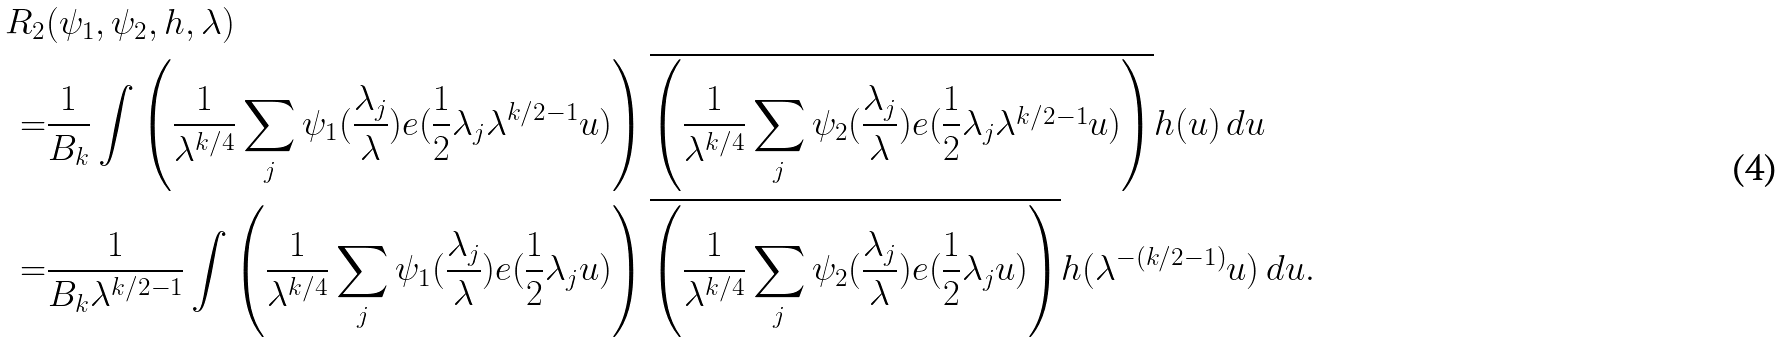Convert formula to latex. <formula><loc_0><loc_0><loc_500><loc_500>R _ { 2 } & ( \psi _ { 1 } , \psi _ { 2 } , h , \lambda ) \\ = & \frac { 1 } { B _ { k } } \int \left ( \frac { 1 } { \lambda ^ { k / 4 } } \sum _ { j } \psi _ { 1 } ( \frac { \lambda _ { j } } { \lambda } ) e ( \frac { 1 } { 2 } \lambda _ { j } \lambda ^ { k / 2 - 1 } u ) \right ) \overline { \left ( \frac { 1 } { \lambda ^ { k / 4 } } \sum _ { j } \psi _ { 2 } ( \frac { \lambda _ { j } } { \lambda } ) e ( \frac { 1 } { 2 } \lambda _ { j } \lambda ^ { k / 2 - 1 } u ) \right ) } h ( u ) \, d u \\ = & \frac { 1 } { B _ { k } \lambda ^ { k / 2 - 1 } } \int \left ( \frac { 1 } { \lambda ^ { k / 4 } } \sum _ { j } \psi _ { 1 } ( \frac { \lambda _ { j } } { \lambda } ) e ( \frac { 1 } { 2 } \lambda _ { j } u ) \right ) \overline { \left ( \frac { 1 } { \lambda ^ { k / 4 } } \sum _ { j } \psi _ { 2 } ( \frac { \lambda _ { j } } { \lambda } ) e ( \frac { 1 } { 2 } \lambda _ { j } u ) \right ) } h ( \lambda ^ { - ( k / 2 - 1 ) } u ) \, d u .</formula> 